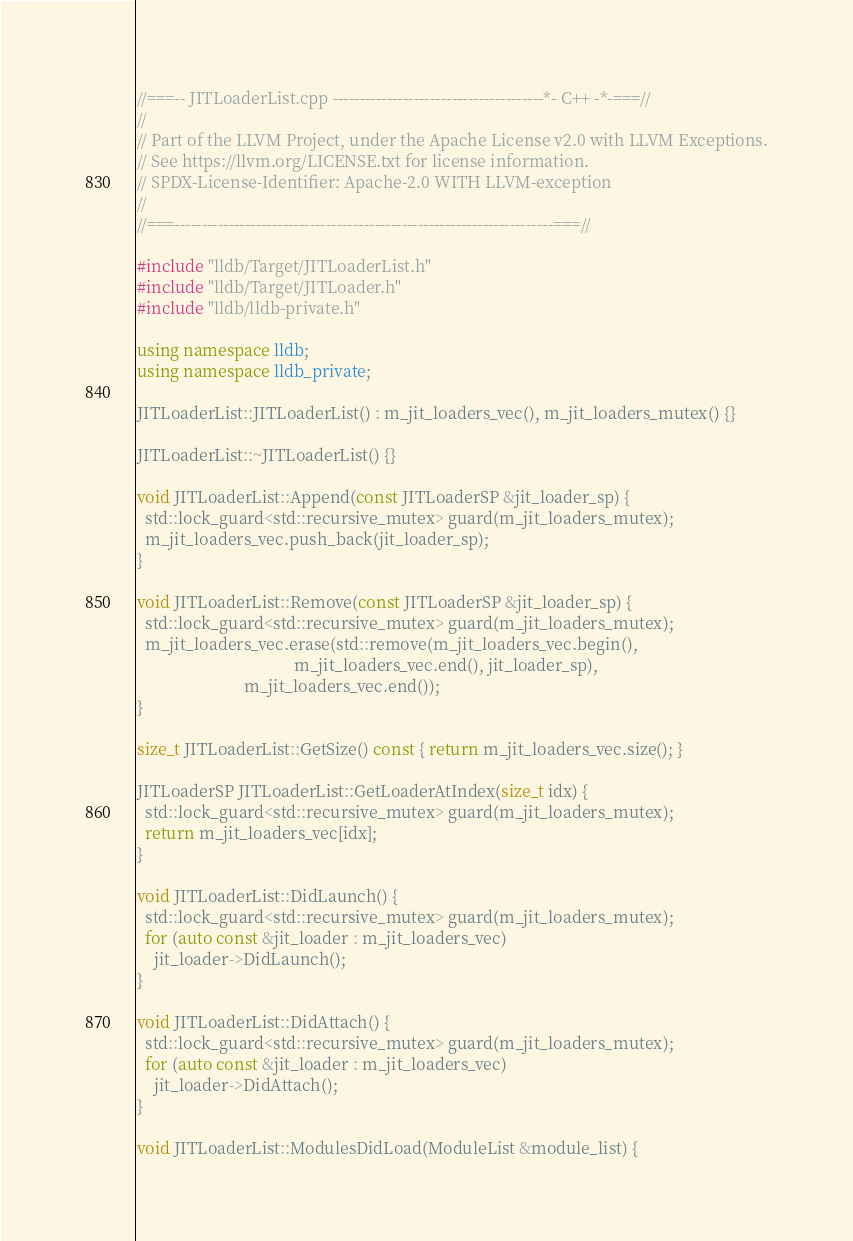Convert code to text. <code><loc_0><loc_0><loc_500><loc_500><_C++_>//===-- JITLoaderList.cpp ---------------------------------------*- C++ -*-===//
//
// Part of the LLVM Project, under the Apache License v2.0 with LLVM Exceptions.
// See https://llvm.org/LICENSE.txt for license information.
// SPDX-License-Identifier: Apache-2.0 WITH LLVM-exception
//
//===----------------------------------------------------------------------===//

#include "lldb/Target/JITLoaderList.h"
#include "lldb/Target/JITLoader.h"
#include "lldb/lldb-private.h"

using namespace lldb;
using namespace lldb_private;

JITLoaderList::JITLoaderList() : m_jit_loaders_vec(), m_jit_loaders_mutex() {}

JITLoaderList::~JITLoaderList() {}

void JITLoaderList::Append(const JITLoaderSP &jit_loader_sp) {
  std::lock_guard<std::recursive_mutex> guard(m_jit_loaders_mutex);
  m_jit_loaders_vec.push_back(jit_loader_sp);
}

void JITLoaderList::Remove(const JITLoaderSP &jit_loader_sp) {
  std::lock_guard<std::recursive_mutex> guard(m_jit_loaders_mutex);
  m_jit_loaders_vec.erase(std::remove(m_jit_loaders_vec.begin(),
                                      m_jit_loaders_vec.end(), jit_loader_sp),
                          m_jit_loaders_vec.end());
}

size_t JITLoaderList::GetSize() const { return m_jit_loaders_vec.size(); }

JITLoaderSP JITLoaderList::GetLoaderAtIndex(size_t idx) {
  std::lock_guard<std::recursive_mutex> guard(m_jit_loaders_mutex);
  return m_jit_loaders_vec[idx];
}

void JITLoaderList::DidLaunch() {
  std::lock_guard<std::recursive_mutex> guard(m_jit_loaders_mutex);
  for (auto const &jit_loader : m_jit_loaders_vec)
    jit_loader->DidLaunch();
}

void JITLoaderList::DidAttach() {
  std::lock_guard<std::recursive_mutex> guard(m_jit_loaders_mutex);
  for (auto const &jit_loader : m_jit_loaders_vec)
    jit_loader->DidAttach();
}

void JITLoaderList::ModulesDidLoad(ModuleList &module_list) {</code> 